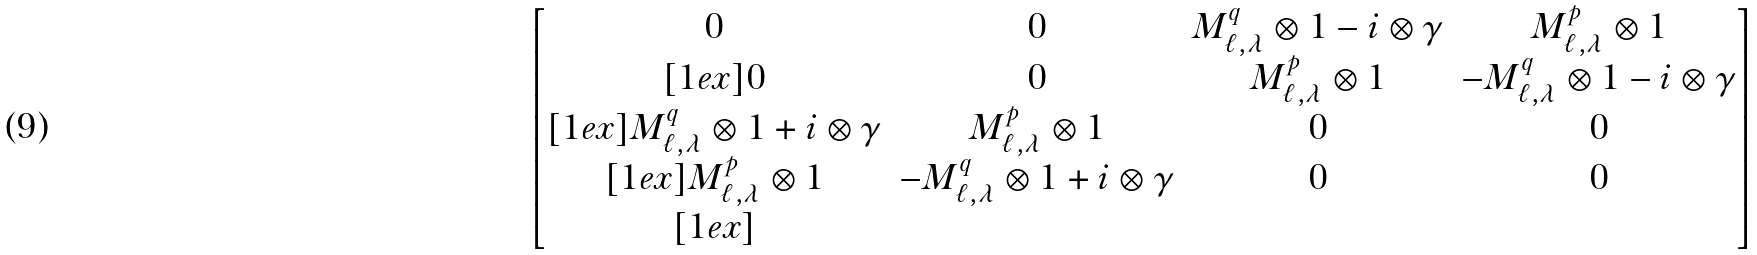<formula> <loc_0><loc_0><loc_500><loc_500>\begin{bmatrix} 0 & 0 & M _ { \ell , \lambda } ^ { q } \otimes 1 - i \otimes \gamma & M _ { \ell , \lambda } ^ { p } \otimes 1 \\ [ 1 e x ] 0 & 0 & M _ { \ell , \lambda } ^ { p } \otimes 1 & - M _ { \ell , \lambda } ^ { q } \otimes 1 - i \otimes \gamma \\ [ 1 e x ] M _ { \ell , \lambda } ^ { q } \otimes 1 + i \otimes \gamma & M _ { \ell , \lambda } ^ { p } \otimes 1 & 0 & 0 \\ [ 1 e x ] M _ { \ell , \lambda } ^ { p } \otimes 1 & - M _ { \ell , \lambda } ^ { q } \otimes 1 + i \otimes \gamma & 0 & 0 \\ [ 1 e x ] \end{bmatrix}</formula> 